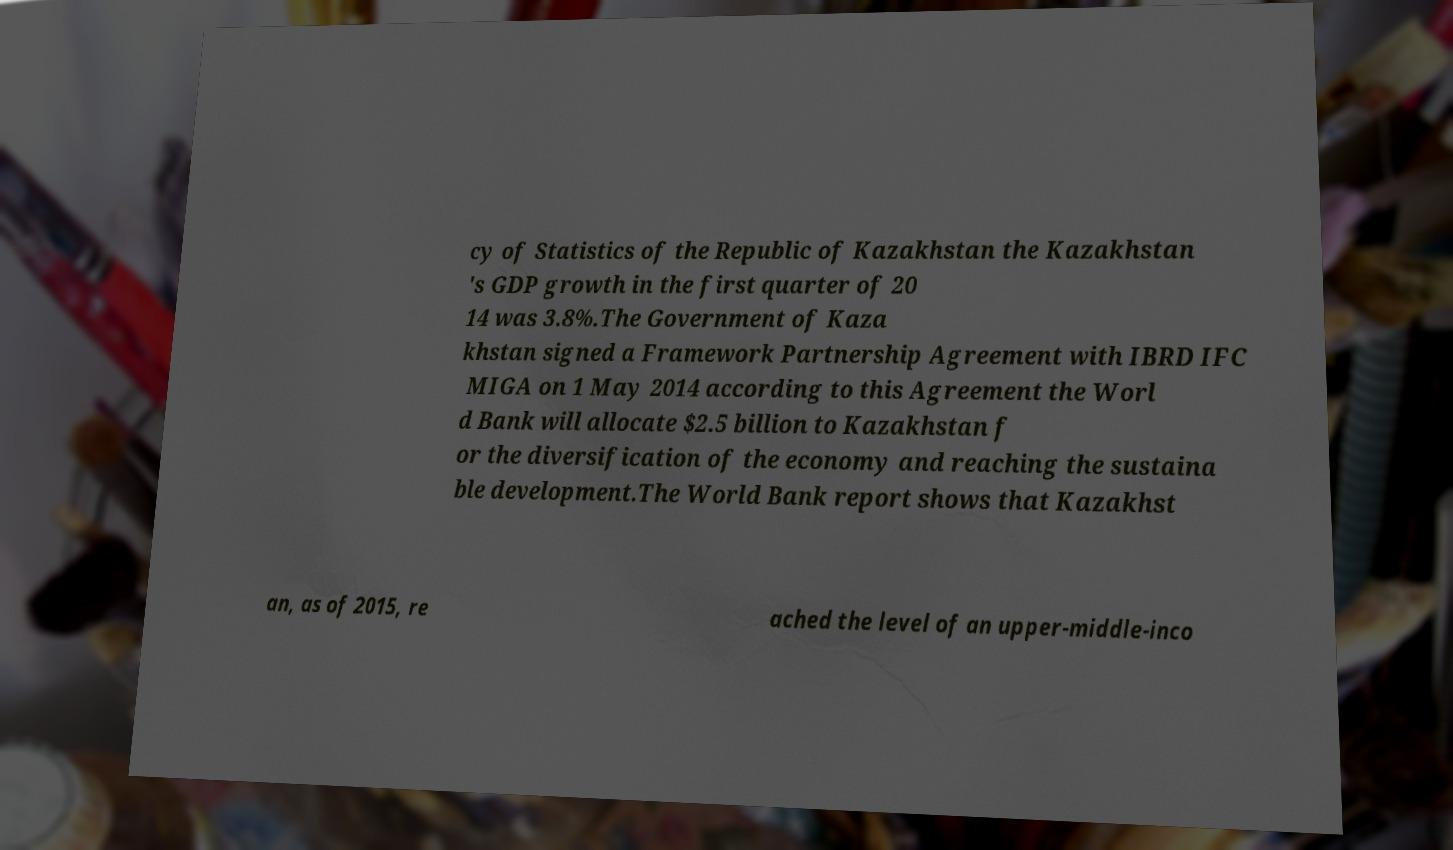Could you extract and type out the text from this image? cy of Statistics of the Republic of Kazakhstan the Kazakhstan 's GDP growth in the first quarter of 20 14 was 3.8%.The Government of Kaza khstan signed a Framework Partnership Agreement with IBRD IFC MIGA on 1 May 2014 according to this Agreement the Worl d Bank will allocate $2.5 billion to Kazakhstan f or the diversification of the economy and reaching the sustaina ble development.The World Bank report shows that Kazakhst an, as of 2015, re ached the level of an upper-middle-inco 